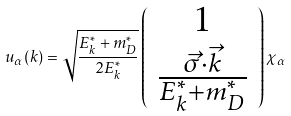<formula> <loc_0><loc_0><loc_500><loc_500>u _ { \alpha } ( k ) = \sqrt { \frac { E _ { k } ^ { * } + m _ { D } ^ { * } } { 2 E _ { k } ^ { * } } } \left ( \begin{array} { c } 1 \\ \frac { \vec { \sigma } \cdot \vec { k } } { E ^ { * } _ { k } + m ^ { * } _ { D } } \end{array} \right ) \chi _ { \alpha }</formula> 